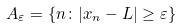<formula> <loc_0><loc_0><loc_500><loc_500>A _ { \varepsilon } = \{ n \colon | x _ { n } - L | \geq \varepsilon \}</formula> 